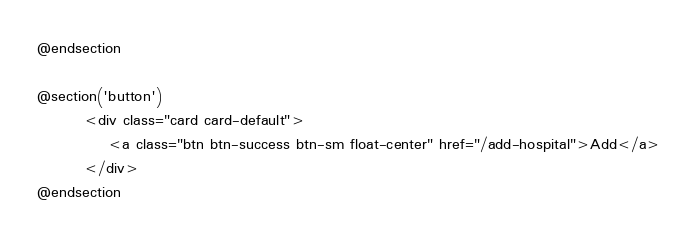<code> <loc_0><loc_0><loc_500><loc_500><_PHP_>
@endsection

@section('button')
        <div class="card card-default">
            <a class="btn btn-success btn-sm float-center" href="/add-hospital">Add</a>
        </div>
@endsection
</code> 